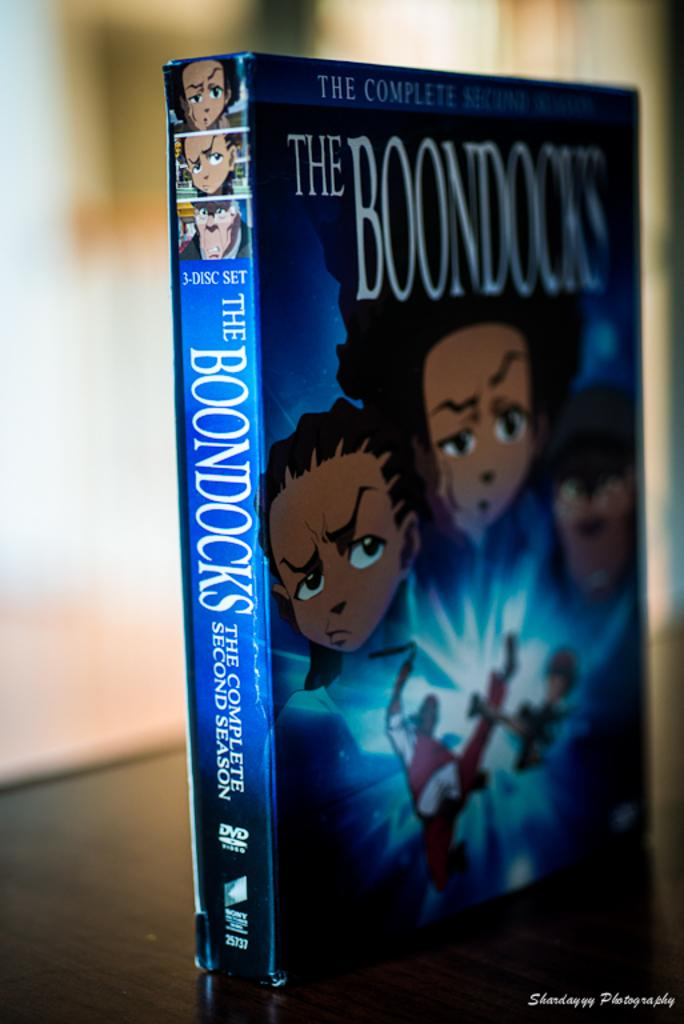What is the main subject of the image? There is a book on a platform in the image. How would you describe the background of the image? The background of the image is blurred. Can you identify any objects in the background of the image? Yes, there are objects visible in the background of the image. What time is displayed on the clock in the image? There is no clock present in the image, so it is not possible to determine the time. 